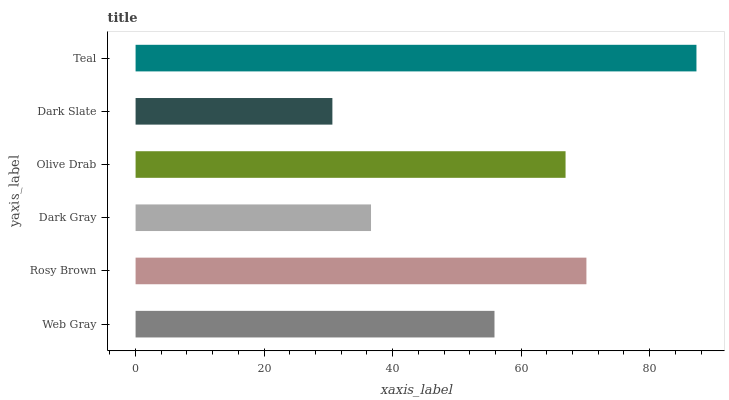Is Dark Slate the minimum?
Answer yes or no. Yes. Is Teal the maximum?
Answer yes or no. Yes. Is Rosy Brown the minimum?
Answer yes or no. No. Is Rosy Brown the maximum?
Answer yes or no. No. Is Rosy Brown greater than Web Gray?
Answer yes or no. Yes. Is Web Gray less than Rosy Brown?
Answer yes or no. Yes. Is Web Gray greater than Rosy Brown?
Answer yes or no. No. Is Rosy Brown less than Web Gray?
Answer yes or no. No. Is Olive Drab the high median?
Answer yes or no. Yes. Is Web Gray the low median?
Answer yes or no. Yes. Is Web Gray the high median?
Answer yes or no. No. Is Olive Drab the low median?
Answer yes or no. No. 